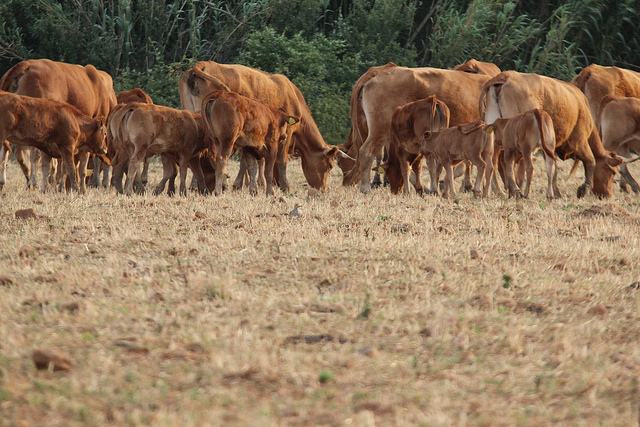If these cows could talk, what do you think they would say about their day? If these cows could talk, they might describe their day as calm and leisurely. They'd likely exchange conversations about the freshness of the grass, the cool breeze, and the joy of sunbathing in the open field. They could share stories about finding the best grazing spots or amusing incidents with their fellow cows. Overall, they'd express contentment with their serene and simple life in the meadow. 